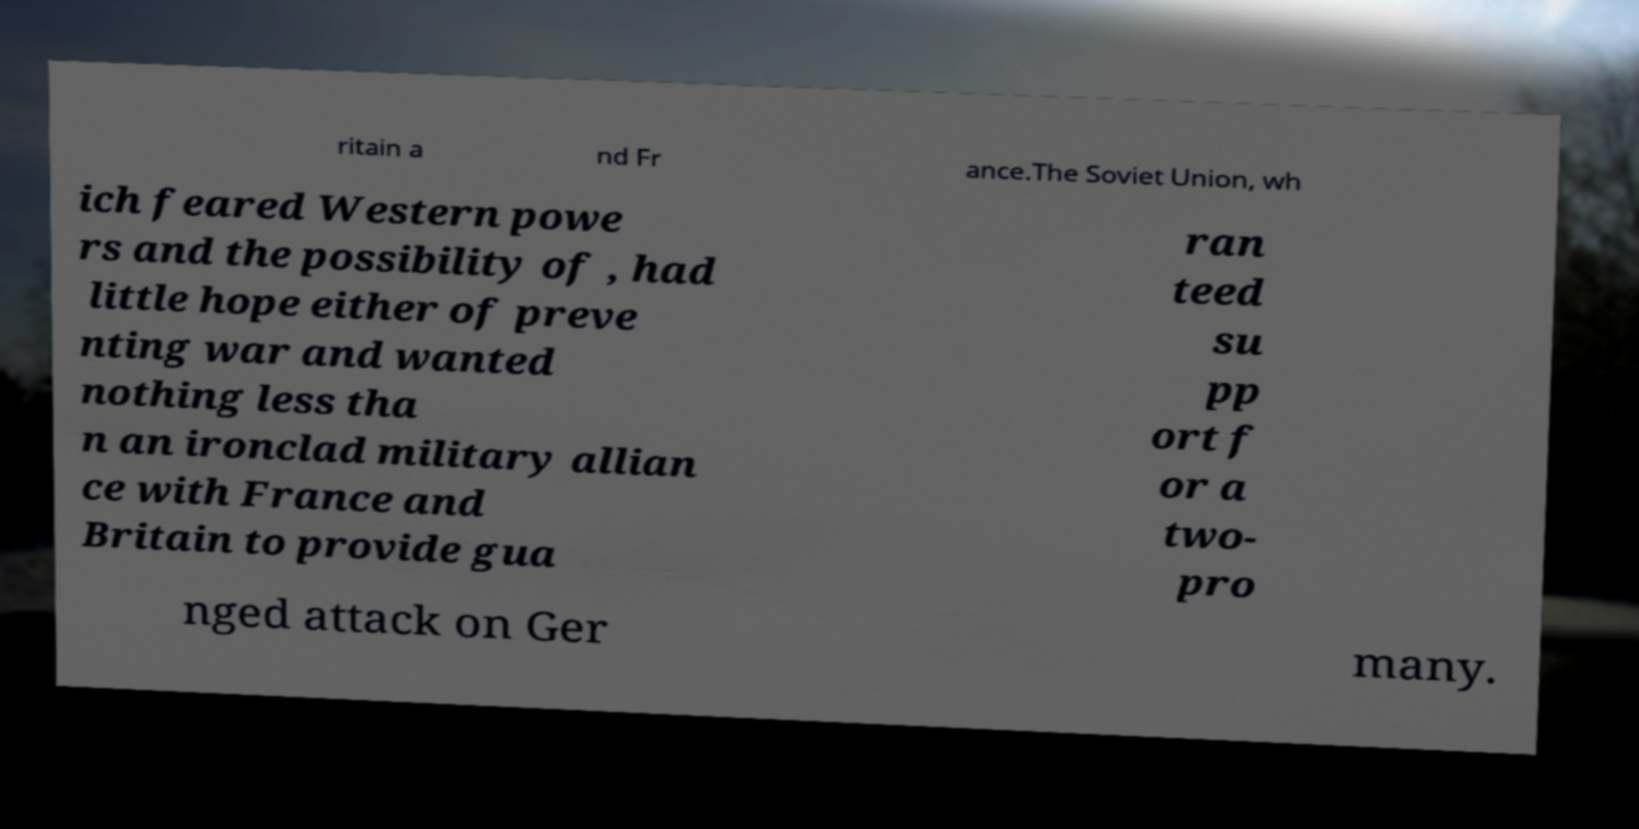Could you assist in decoding the text presented in this image and type it out clearly? ritain a nd Fr ance.The Soviet Union, wh ich feared Western powe rs and the possibility of , had little hope either of preve nting war and wanted nothing less tha n an ironclad military allian ce with France and Britain to provide gua ran teed su pp ort f or a two- pro nged attack on Ger many. 